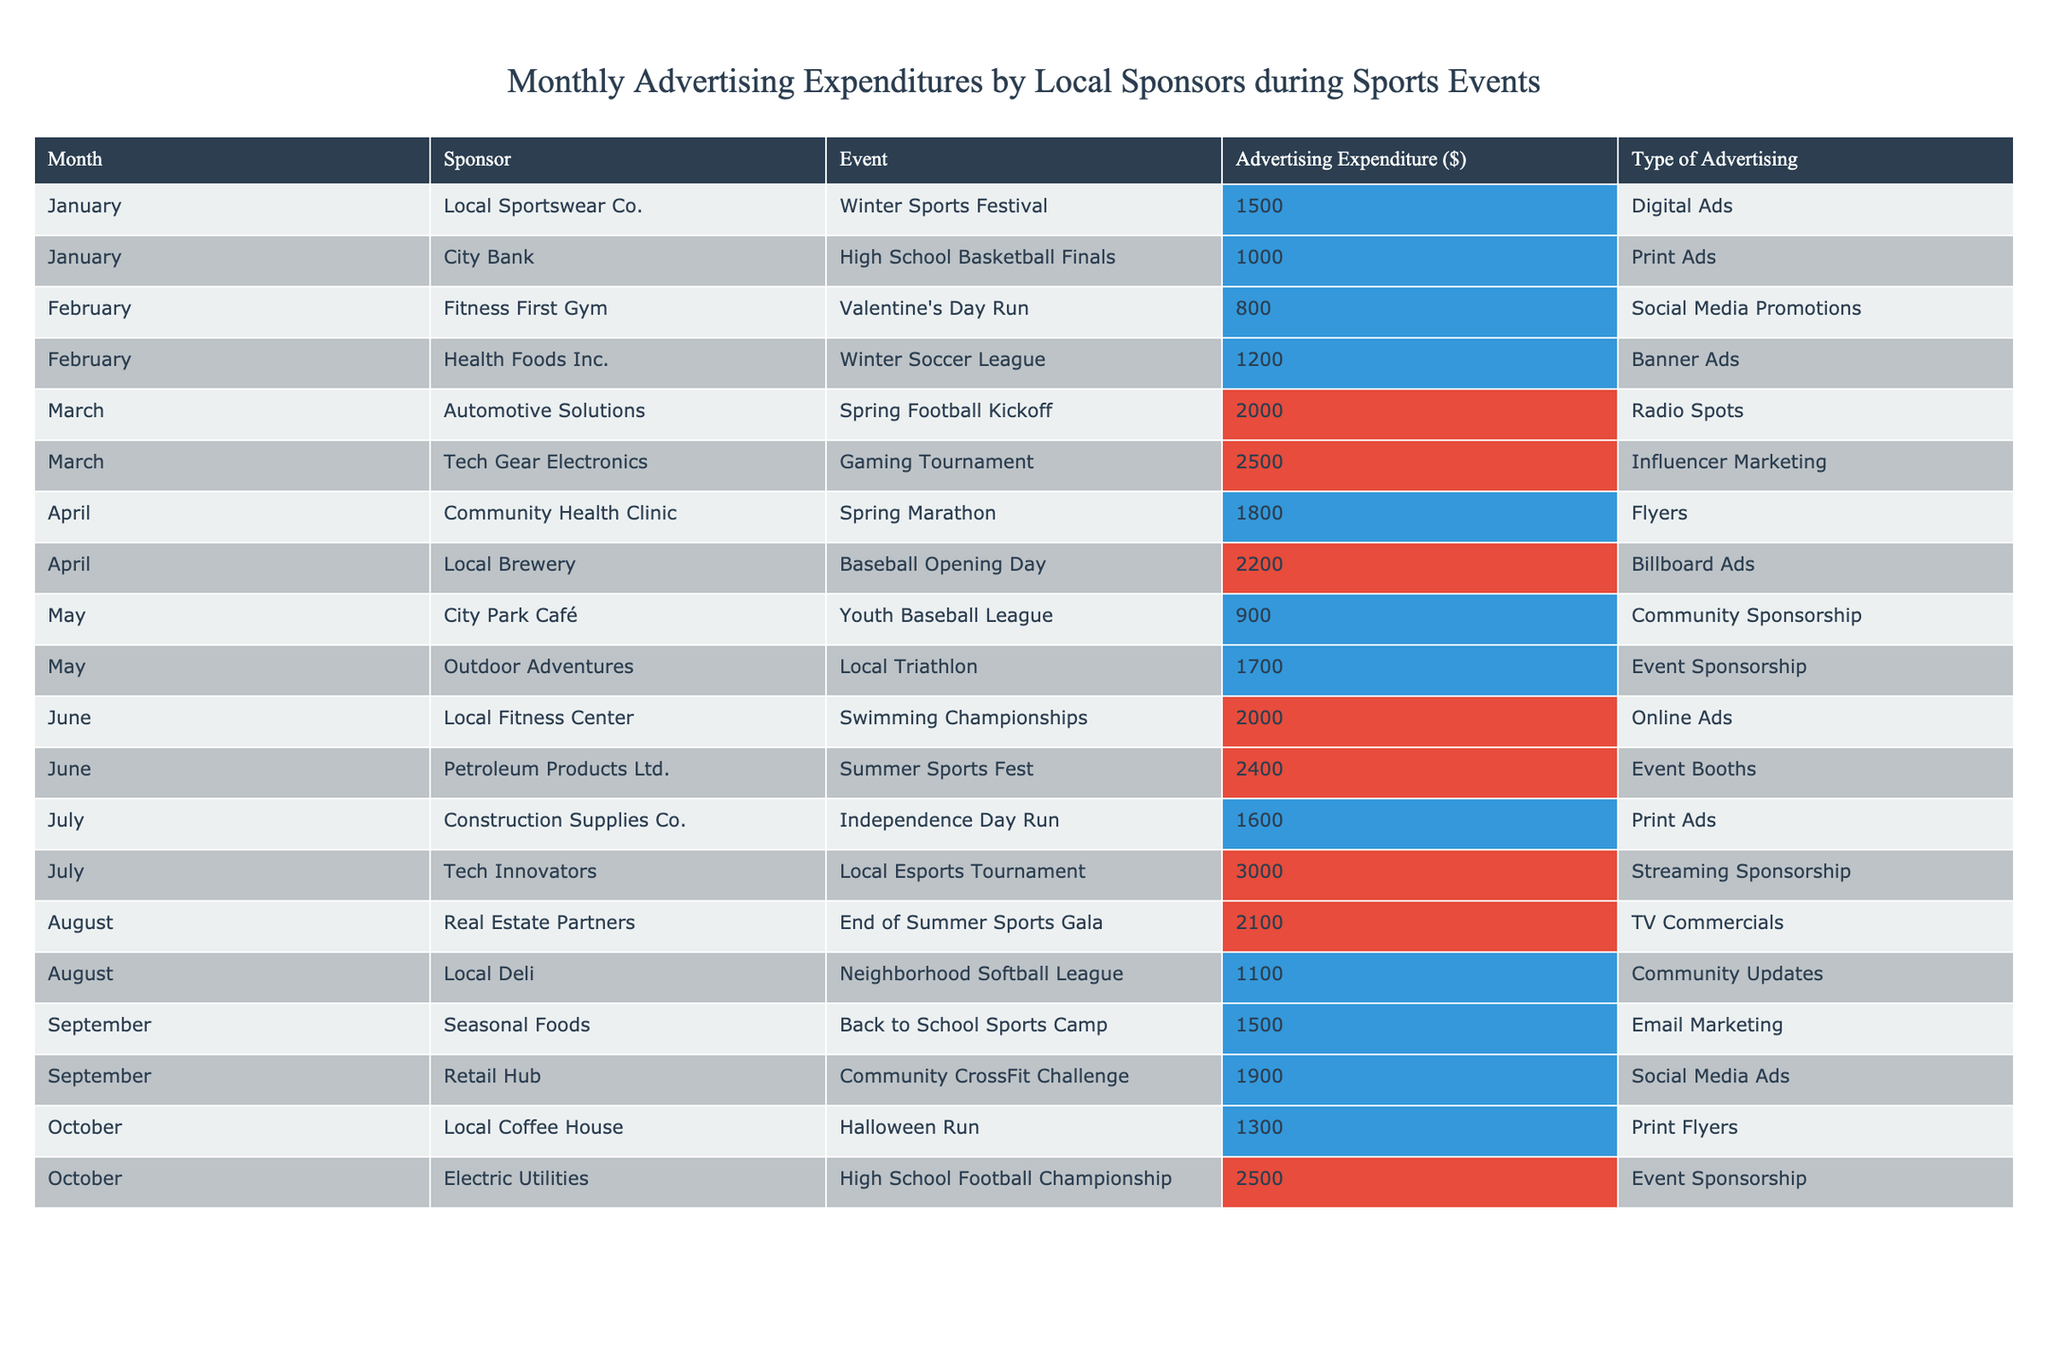What sponsor had the highest advertising expenditure in March? In March, Tech Gear Electronics had the highest expenditure of $2500 during the Gaming Tournament, which is listed in the table.
Answer: Tech Gear Electronics What was the total advertising expenditure for the events held in July? The events in July had expenditures of $1600 for the Independence Day Run and $3000 for the Local Esports Tournament. Adding these amounts gives $1600 + $3000 = $4600.
Answer: $4600 Did Local Sportswear Co. sponsor any events in the month of January? Yes, Local Sportswear Co. sponsored the Winter Sports Festival in January, with an expenditure of $1500.
Answer: Yes What type of advertising did Health Foods Inc. use for the Winter Soccer League? Health Foods Inc. used Banner Ads for the Winter Soccer League, as indicated in the table.
Answer: Banner Ads Which month had the lowest total advertising expenditure across all sponsors? To find the month with the lowest total expenditure, we sum the expenditures for each month: January ($2500), February ($2000), March ($4500), April ($4000), May ($2600), June ($4400), July ($4600), August ($3200), September ($3400), October ($3800). January has the lowest total expenditure of $2500.
Answer: January What percentage of the total advertising expenditure in August was spent on Community Updates by Local Deli? In August, the total expenditure was $2100 + $1100 = $3200. Local Deli spent $1100. Calculating percentage: ($1100 / $3200) * 100 = 34.375%.
Answer: 34.375% Was the expenditure on the Halloween Run greater than that on the High School Football Championship? The expenditure for the Halloween Run was $1300, while the High School Football Championship's expenditure was $2500. Since $1300 is less than $2500, the statement is false.
Answer: No What are the average advertising expenditures for the events held in June and July combined? For June, the expenditures are $2000 and $2400, giving a total of $4400. For July, the expenditures are $1600 and $3000, giving a total of $4600. Combined, the total is $4400 + $4600 = $9000. The average is $9000 / 4 = $2250.
Answer: $2250 